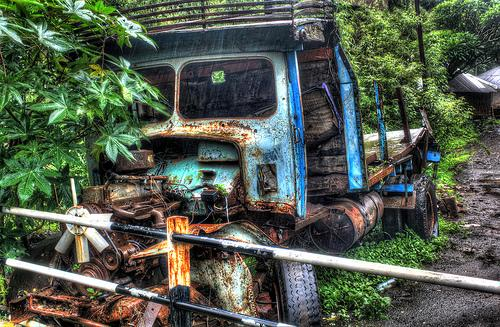Express the main idea of the image as briefly as possible. The central theme is an aged, rusty truck surrounded by foliage, fence, and a distant building. Describe the image in a single sentence by focusing on the main subject and its notable features. The image showcases an old, rusty blue truck with flat tires, surrounded by wet green leaves, bushes, and a metal fence. Summarize the most prominent features of the image in a single sentence. The image highlights a dilapidated blue truck amidst a metal fence, green leaves, and bushes with a distant building. Highlight the key components of the image in a concise manner. A rusted blue truck, flat tires, metal fence, green foliage, and a building form the main components of the image. In one sentence, describe the dominant object in the image and how it relates to its environment. A decrepit blue truck with rust and flat tires sits amidst wet green leaves, bushes, and a metal fence. Write a short summary of the most significant aspects of the image. The picture features a dilapidated blue truck, a metal fence, wet green foliage, and a building in the background. State the primary elements of the scene portrayed in the image. The scene includes an old blue truck, metal fence railing, wet green leaves, bushes, and a distant building. Provide a brief description of the primary focus of the image. An old broken blue truck with rust, flat tires, and green marks, surrounded by wet green leaves and bushes. Mention the central object in the image and some surrounding elements. An old rusty truck is in the center, with a fence railing, green leaves, bushes, and a building nearby. Briefly describe the main subject of the image and its surroundings. The image focuses on an old, rusty blue truck surrounded by wet green foliage, a metal fence, and a building in the background. 